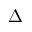<formula> <loc_0><loc_0><loc_500><loc_500>\Delta</formula> 